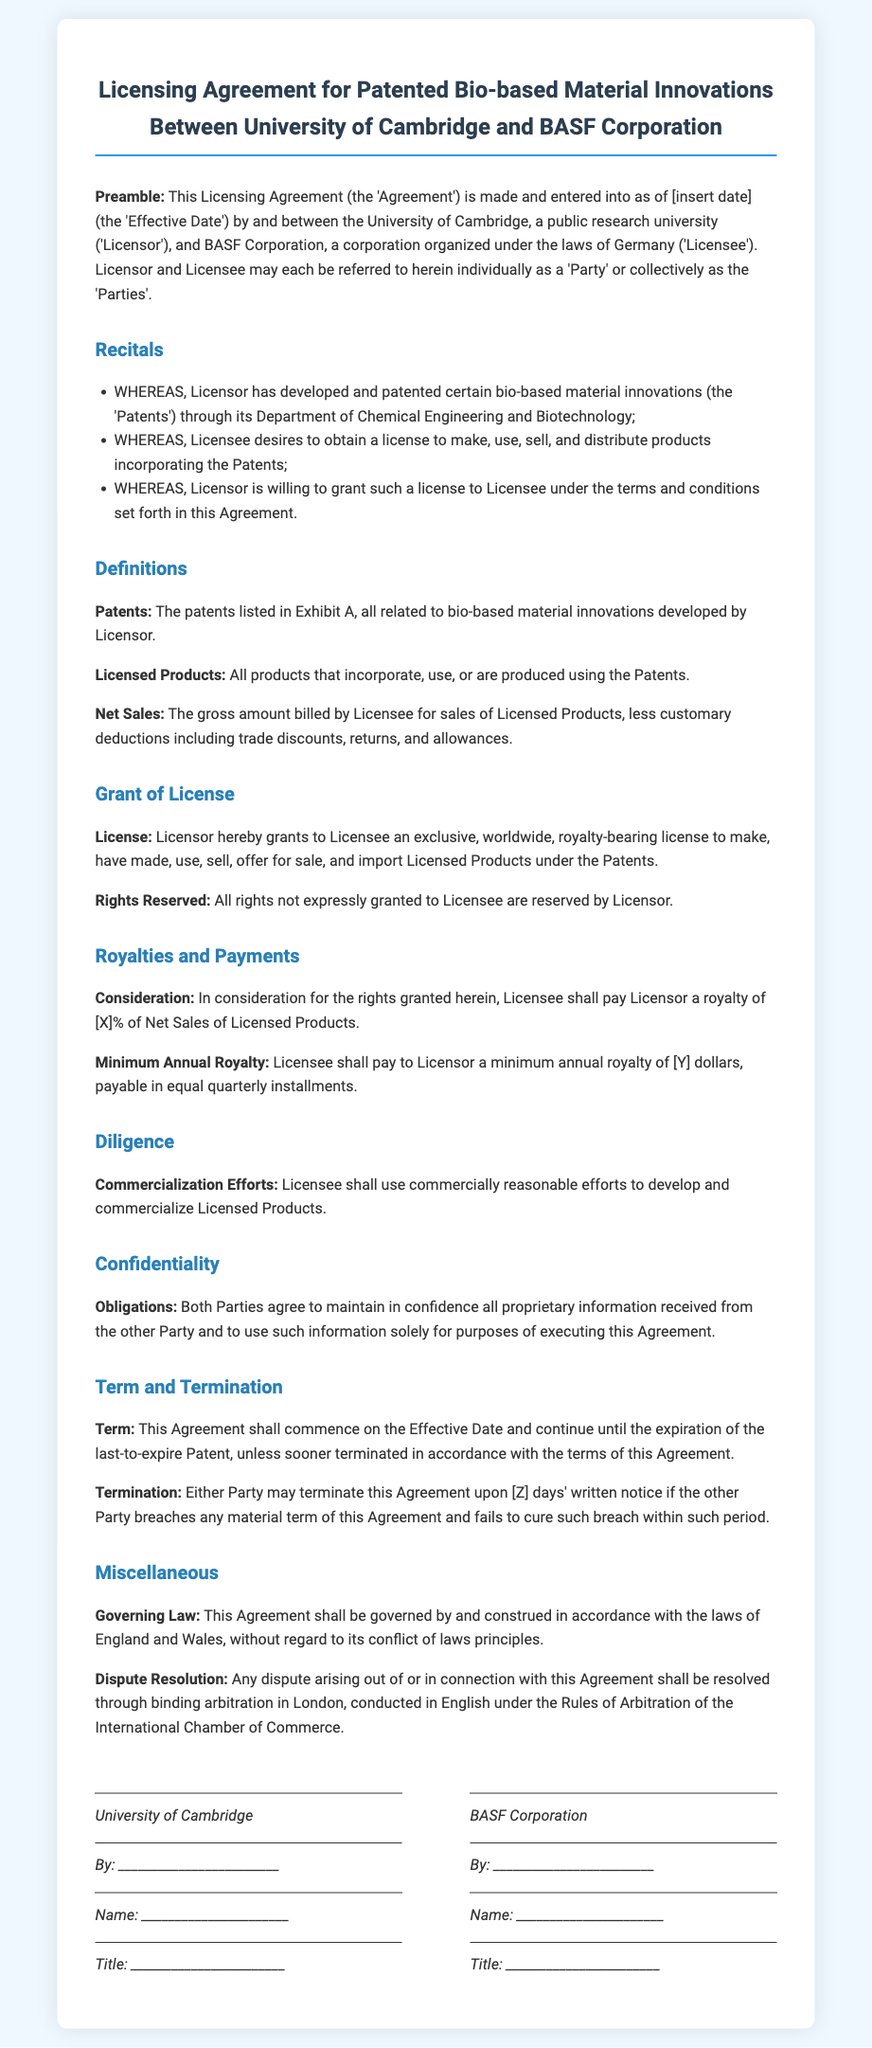What is the Effective Date of the Agreement? The specific date for the Effective Date is not provided and is marked as [insert date].
Answer: [insert date] Who are the Parties involved in this Agreement? The Parties are the University of Cambridge and BASF Corporation.
Answer: University of Cambridge and BASF Corporation What is the royalty percentage expressed as [X]? The document states that the royalty to be paid is expressed as [X]% of Net Sales, and does not specify the exact number.
Answer: [X]% What is the minimum annual royalty expressed as [Y]? The document states the minimum annual royalty is expressed as [Y] dollars, without specifying the exact amount.
Answer: [Y] What is the duration of the Agreement? The Agreement lasts until the expiration of the last-to-expire Patent unless terminated earlier.
Answer: Until the expiration of the last-to-expire Patent What is the governing law mentioned in the document? The governing law for this Agreement is specified as the laws of England and Wales.
Answer: England and Wales Under what circumstances can the Agreement be terminated? The Agreement can be terminated if either Party breaches any material term and fails to cure such breach within a specified notice period.
Answer: Breach of material term What is the primary obligation of Licensee regarding commercialization? The Licensee must use commercially reasonable efforts to develop and commercialize Licensed Products.
Answer: Commercially reasonable efforts What type of license is granted to Licensee? The License is described as an exclusive, worldwide, royalty-bearing license.
Answer: Exclusive, worldwide, royalty-bearing license What is required by both Parties regarding proprietary information? Both Parties must maintain the confidentiality of proprietary information received from each other.
Answer: Maintain confidentiality 